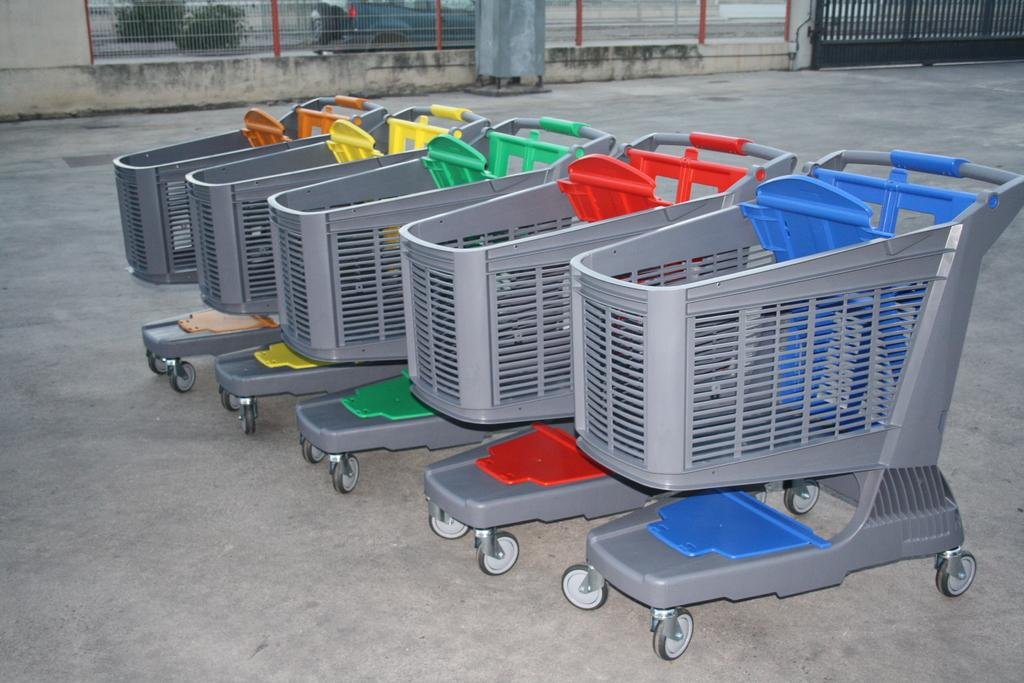What type of transportation can be seen in the image? There is a vehicle in the image. What structures are present in the image? There is a gate, fencing, and a wall in the image. What else can be seen in the image besides the structures? There are trolleys, plants, and a vehicle in the image. What type of ship can be seen sailing in the image? There is no ship present in the image. Can you tell me a joke that is related to the image? The provided information does not include any jokes, and the image does not contain any elements that would suggest a joke. 